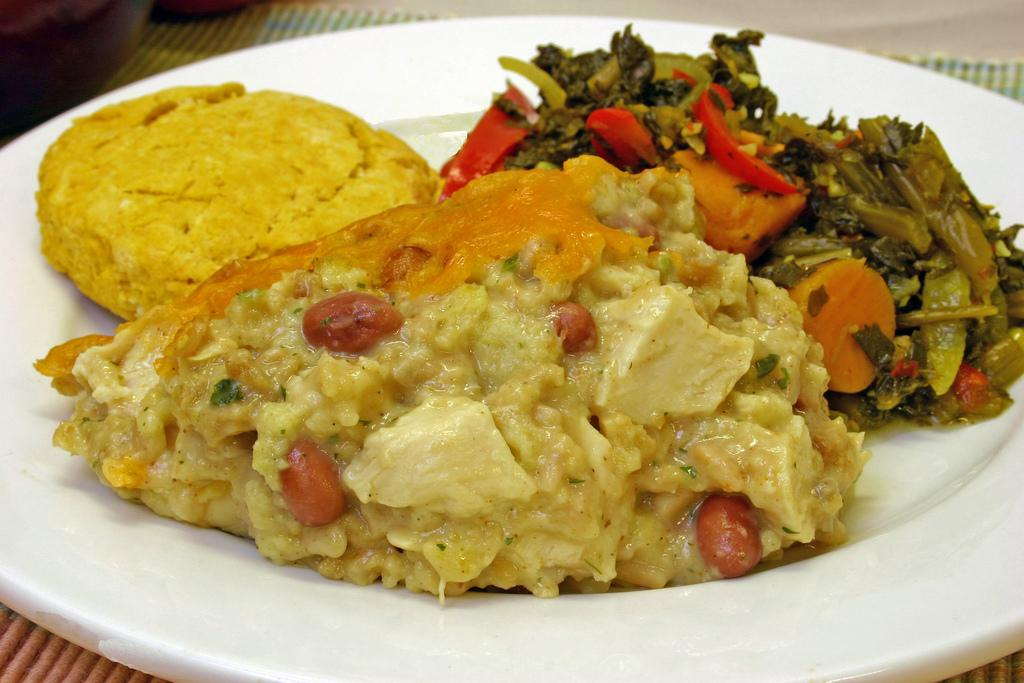What is the main subject of the image? The main subject of the image is food. What can be observed about the plate the food is on? The plate is white in color. How many colors can be seen in the food? The food has various colors, including brown, red, orange, green, and cream. Where is the plate with food located? The plate is on a table. Can you see any kettles boiling water on the table in the image? There is no kettle present in the image. What type of sticks are used to eat the food in the image? The image does not show any sticks being used to eat the food. 